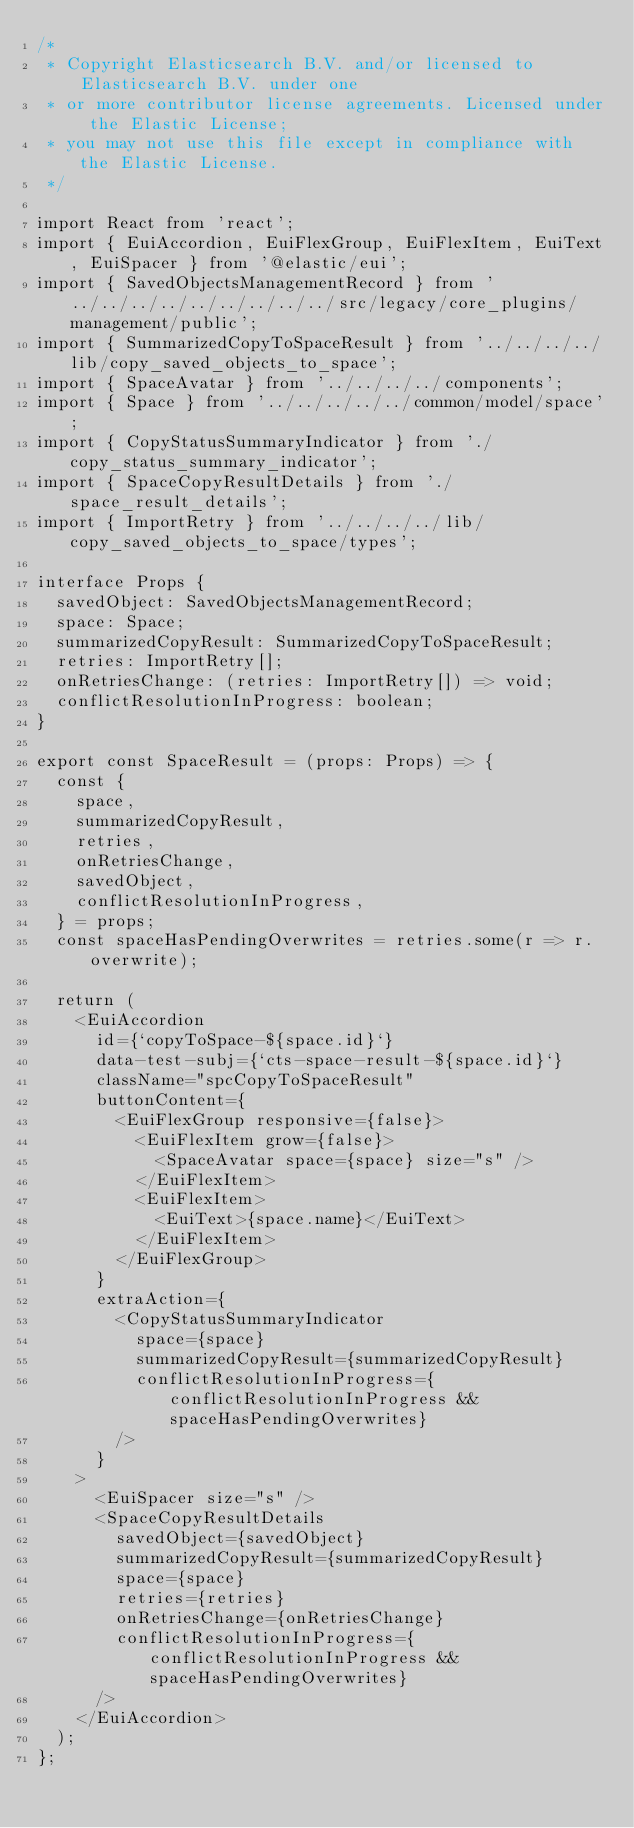Convert code to text. <code><loc_0><loc_0><loc_500><loc_500><_TypeScript_>/*
 * Copyright Elasticsearch B.V. and/or licensed to Elasticsearch B.V. under one
 * or more contributor license agreements. Licensed under the Elastic License;
 * you may not use this file except in compliance with the Elastic License.
 */

import React from 'react';
import { EuiAccordion, EuiFlexGroup, EuiFlexItem, EuiText, EuiSpacer } from '@elastic/eui';
import { SavedObjectsManagementRecord } from '../../../../../../../../../src/legacy/core_plugins/management/public';
import { SummarizedCopyToSpaceResult } from '../../../../lib/copy_saved_objects_to_space';
import { SpaceAvatar } from '../../../../components';
import { Space } from '../../../../../common/model/space';
import { CopyStatusSummaryIndicator } from './copy_status_summary_indicator';
import { SpaceCopyResultDetails } from './space_result_details';
import { ImportRetry } from '../../../../lib/copy_saved_objects_to_space/types';

interface Props {
  savedObject: SavedObjectsManagementRecord;
  space: Space;
  summarizedCopyResult: SummarizedCopyToSpaceResult;
  retries: ImportRetry[];
  onRetriesChange: (retries: ImportRetry[]) => void;
  conflictResolutionInProgress: boolean;
}

export const SpaceResult = (props: Props) => {
  const {
    space,
    summarizedCopyResult,
    retries,
    onRetriesChange,
    savedObject,
    conflictResolutionInProgress,
  } = props;
  const spaceHasPendingOverwrites = retries.some(r => r.overwrite);

  return (
    <EuiAccordion
      id={`copyToSpace-${space.id}`}
      data-test-subj={`cts-space-result-${space.id}`}
      className="spcCopyToSpaceResult"
      buttonContent={
        <EuiFlexGroup responsive={false}>
          <EuiFlexItem grow={false}>
            <SpaceAvatar space={space} size="s" />
          </EuiFlexItem>
          <EuiFlexItem>
            <EuiText>{space.name}</EuiText>
          </EuiFlexItem>
        </EuiFlexGroup>
      }
      extraAction={
        <CopyStatusSummaryIndicator
          space={space}
          summarizedCopyResult={summarizedCopyResult}
          conflictResolutionInProgress={conflictResolutionInProgress && spaceHasPendingOverwrites}
        />
      }
    >
      <EuiSpacer size="s" />
      <SpaceCopyResultDetails
        savedObject={savedObject}
        summarizedCopyResult={summarizedCopyResult}
        space={space}
        retries={retries}
        onRetriesChange={onRetriesChange}
        conflictResolutionInProgress={conflictResolutionInProgress && spaceHasPendingOverwrites}
      />
    </EuiAccordion>
  );
};
</code> 